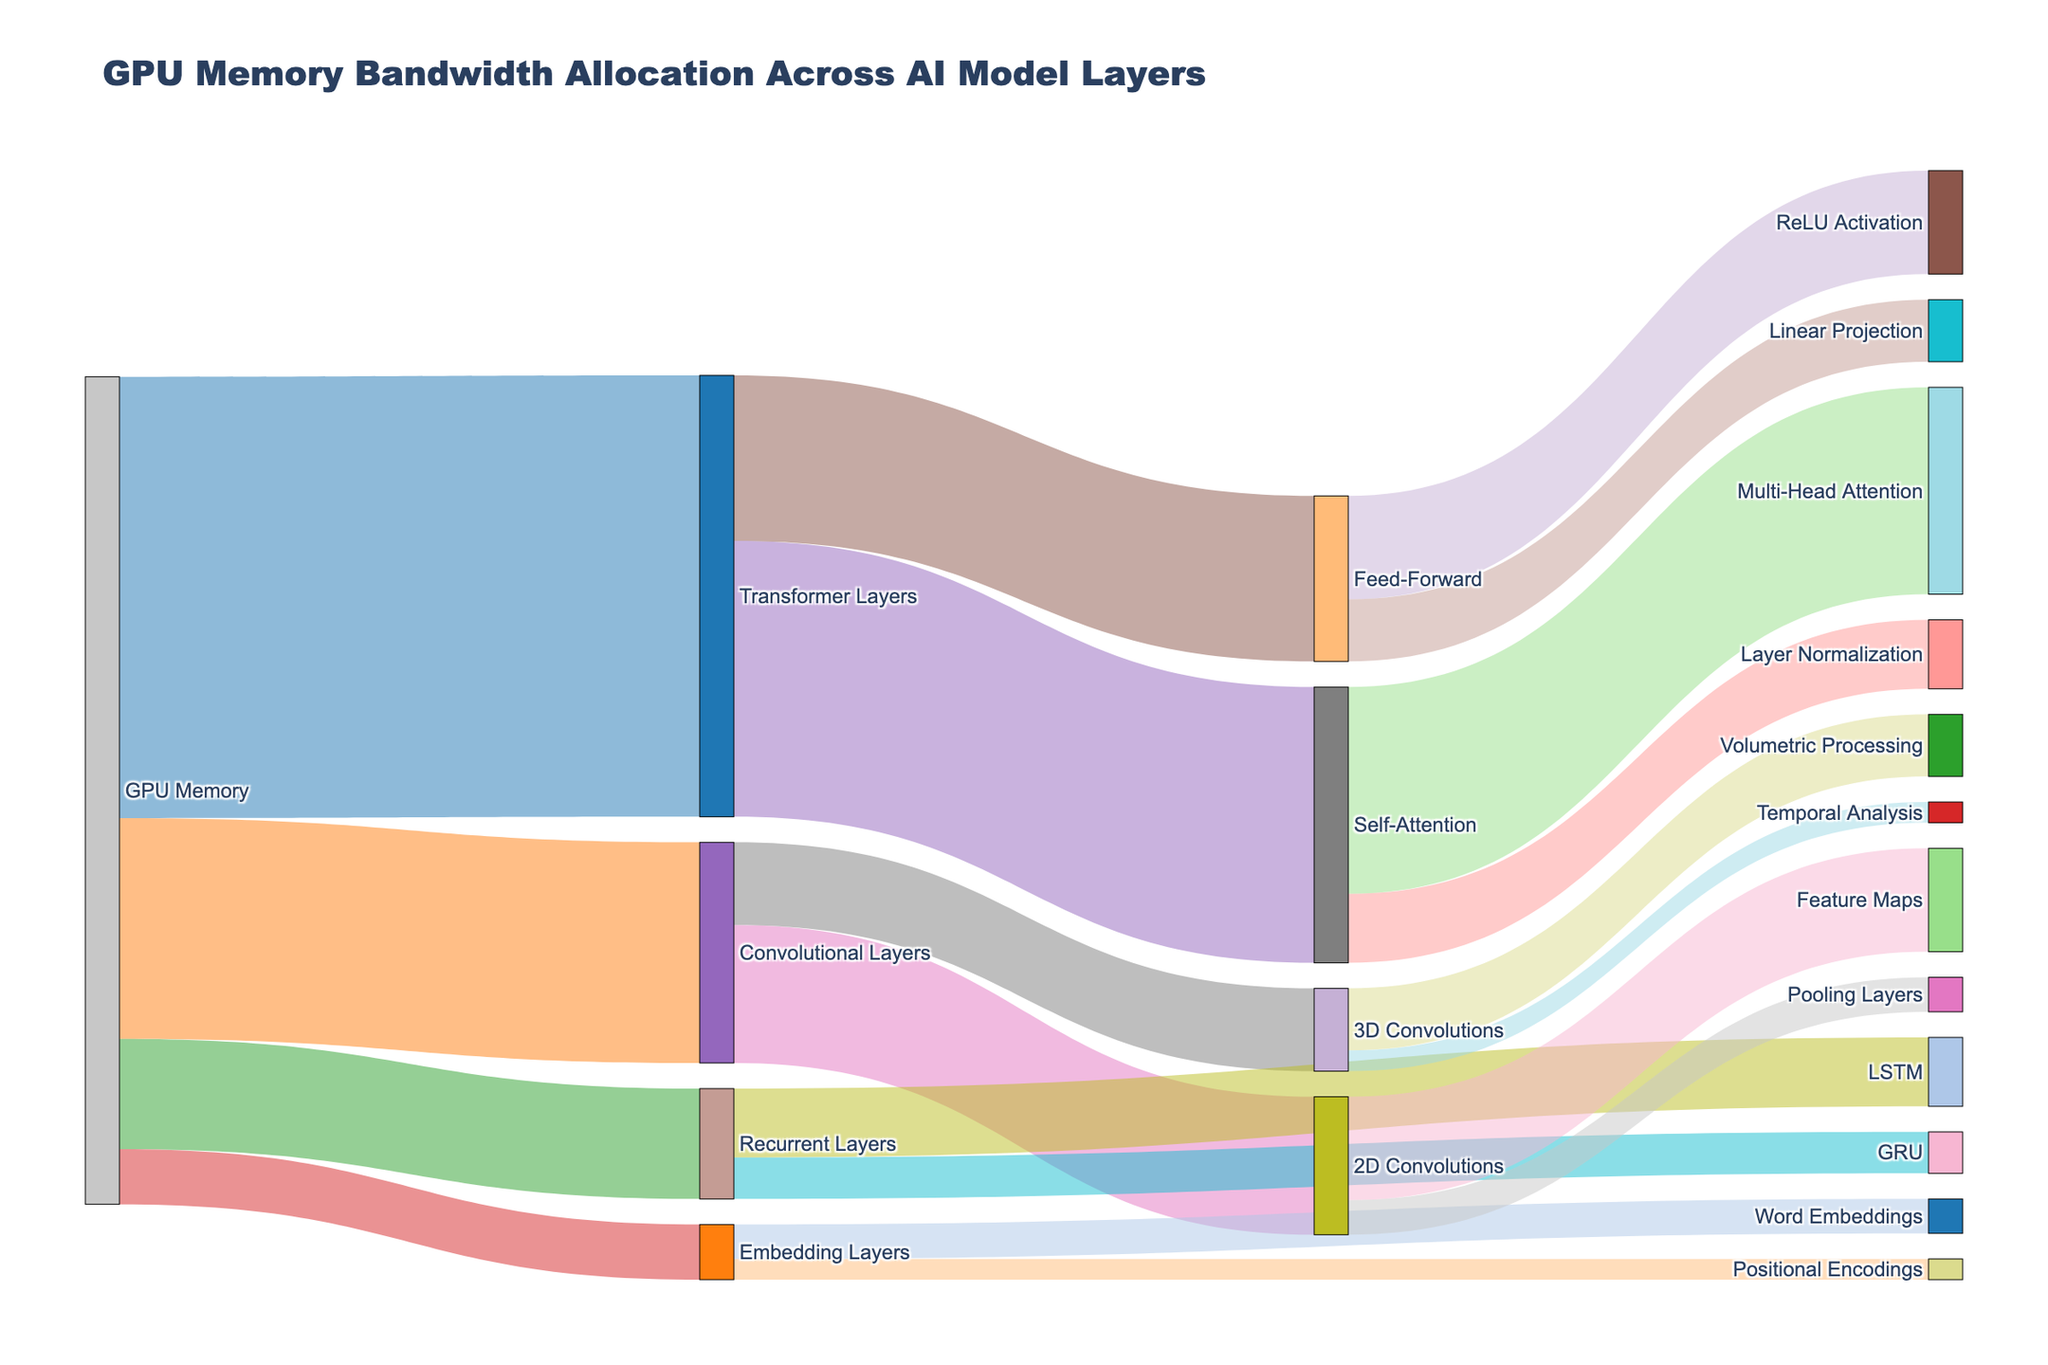How much GPU memory is allocated to the Convolutional Layers? The GPU memory allocated to Convolutional Layers is directly visible and is labeled as "64" in the figure.
Answer: 64 What is the total GPU memory allocation for the Transformer Layers and Embedding Layers? The Transformer Layers are allocated 128 units of GPU memory and the Embedding Layers are allocated 16 units. Summing these gives 128 + 16 = 144.
Answer: 144 Which sub-layer within the Transformer Layer has the highest memory allocation? The Transformer Layer is divided into Self-Attention and Feed-Forward sub-layers. Self-Attention has 80 units and Feed-Forward has 48 units, hence Self-Attention has the highest allocation.
Answer: Self-Attention Compare the memory allocations of 2D Convolutions and LSTM under their respective layers. Which one has more, and by how much? The 2D Convolutions layer has an allocation of 40 units, and LSTM has an allocation of 20 units under the Recurrent Layers. The difference is 40 - 20 = 20 units.
Answer: 2D Convolutions by 20 units What percentage of GPU memory allocated to Transformer Layers is used by Feed-Forward? The Transformer Layers have 128 units total, and the Feed-Forward sub-layer uses 48 units. The percentage is (48 / 128) * 100 = 37.5%.
Answer: 37.5% Which specific layer has the lowest memory allocation and how much is it? The Positional Encodings within the Embedding Layers have the lowest allocation, which is 6 units.
Answer: Positional Encodings, 6 How is the memory distributed within the Self-Attention sub-layer? Self-Attention is divided into Multi-Head Attention with 60 units and Layer Normalization with 20 units.
Answer: Multi-Head Attention: 60, Layer Normalization: 20 What is the combined memory allocation for 3D Convolutions and GRU layers? The 3D Convolutions have 24 units and the GRU layers have 12 units. The combined total is 24 + 12 = 36.
Answer: 36 Identify the layer that has the highest allocation within the Convolutional Layers and specify its value. Within the Convolutional Layers, the sub-layer 2D Convolutions has 40 units of memory, which is the highest compared to 3D Convolutions.
Answer: 2D Convolutions, 40 How much memory is used by the pooling layers in 2D Convolutions compared to the Linear Projection in Feed-Forward? Pooling Layers in 2D Convolutions receive 10 units, whereas Linear Projection in Feed-Forward gets 18 units. Linear Projection uses 8 units more than Pooling Layers.
Answer: Linear Projection by 8 units 